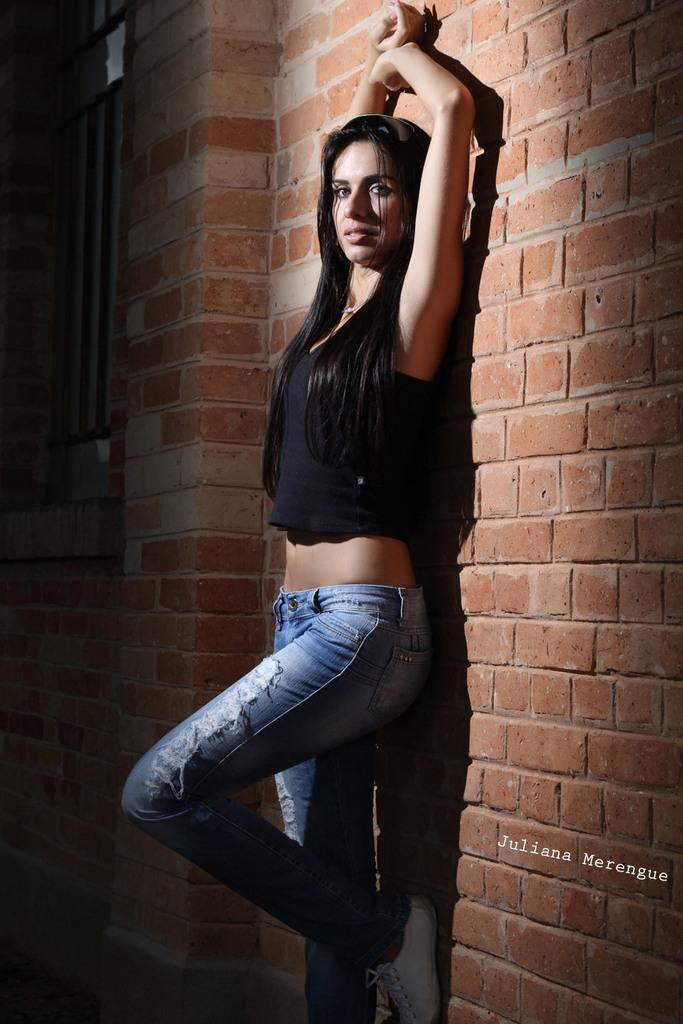Who is present in the image? There is a woman standing in the image. What can be seen behind the woman? There is a brick wall visible in the image. What type of wine is the woman holding in the image? There is no wine present in the image; the woman is not holding anything. 